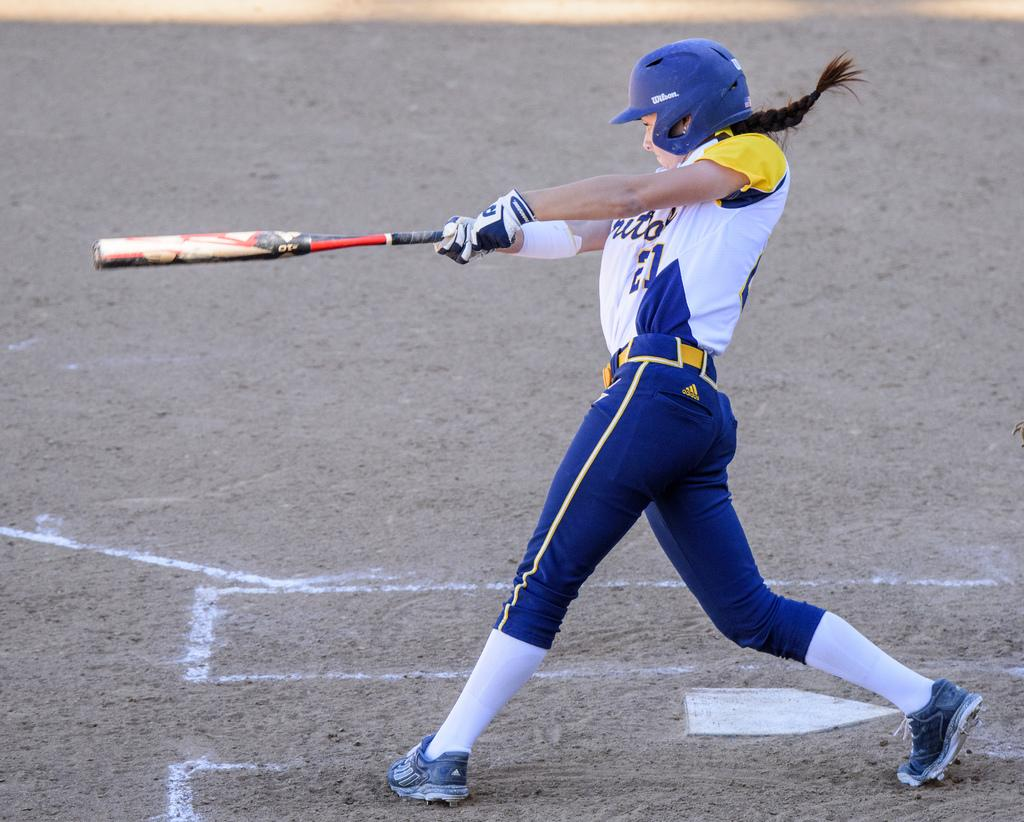Who is the main subject in the image? There is a girl in the image. Where is the girl located in the image? The girl is on the left side of the image. What is the girl holding in her hands? The girl is holding a bat in her hands. What type of zipper can be seen on the girl's clothing in the image? There is no zipper visible on the girl's clothing in the image. Can you tell me how many tomatoes are on the ground near the girl? There are no tomatoes present in the image. 